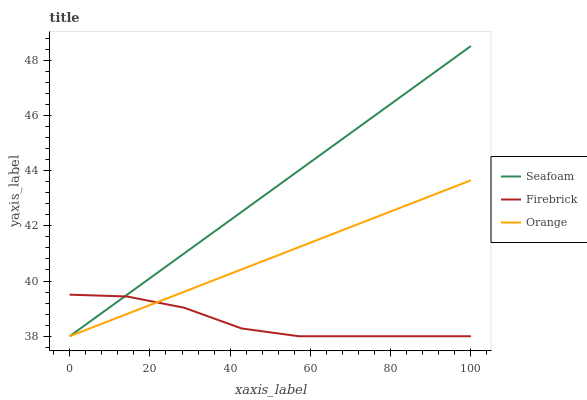Does Firebrick have the minimum area under the curve?
Answer yes or no. Yes. Does Seafoam have the maximum area under the curve?
Answer yes or no. Yes. Does Seafoam have the minimum area under the curve?
Answer yes or no. No. Does Firebrick have the maximum area under the curve?
Answer yes or no. No. Is Orange the smoothest?
Answer yes or no. Yes. Is Firebrick the roughest?
Answer yes or no. Yes. Is Seafoam the smoothest?
Answer yes or no. No. Is Seafoam the roughest?
Answer yes or no. No. Does Orange have the lowest value?
Answer yes or no. Yes. Does Seafoam have the highest value?
Answer yes or no. Yes. Does Firebrick have the highest value?
Answer yes or no. No. Does Seafoam intersect Firebrick?
Answer yes or no. Yes. Is Seafoam less than Firebrick?
Answer yes or no. No. Is Seafoam greater than Firebrick?
Answer yes or no. No. 